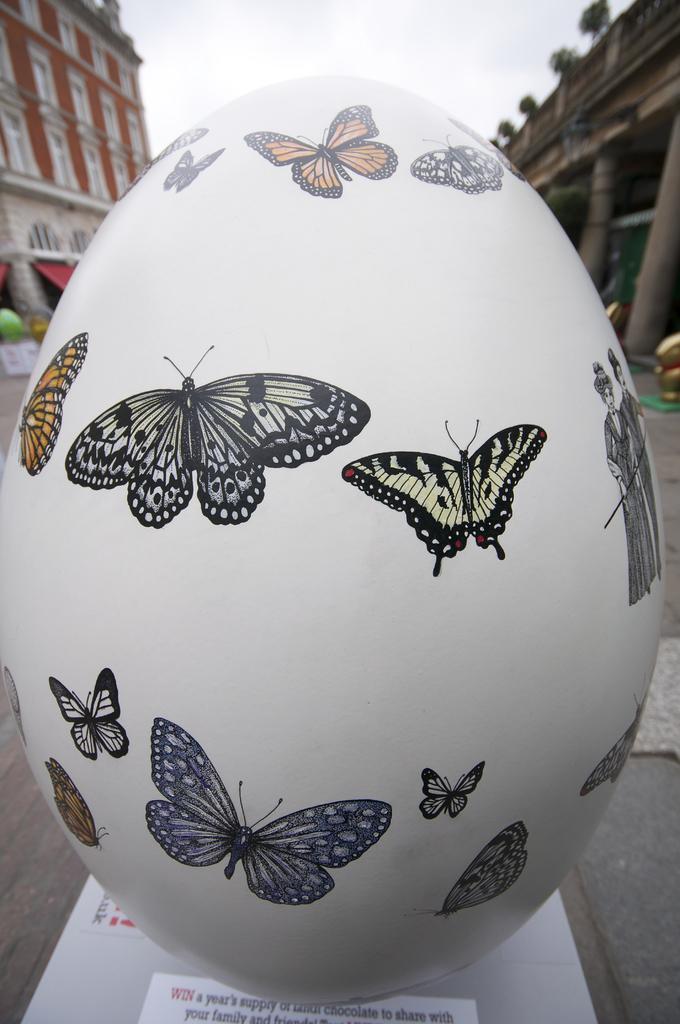In one or two sentences, can you explain what this image depicts? In the center of the image we can see one white color object. On the object, we can see papers and one egg shaped object. On the egg shaped object, we can see some painting, in which we can see a few butterflies. On the papers, we can see some text. In the background we can see the sky, clouds, buildings, pillars, white color object and a few other objects. 